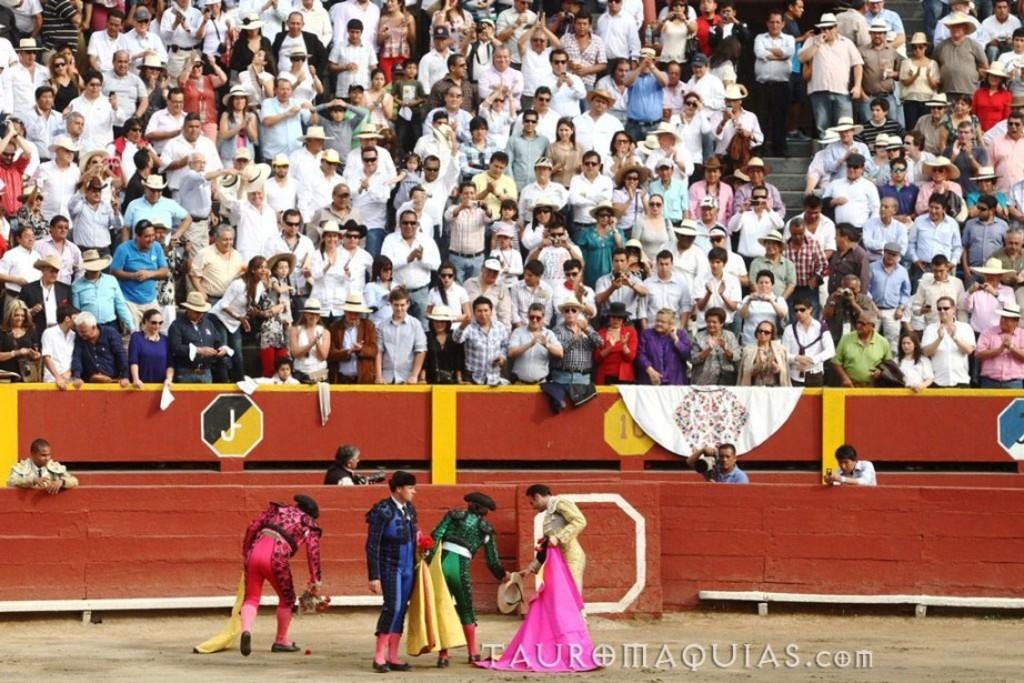What activity are the people in the image participating in? The people in the image are standing in a court and catching a cloth. What type of structure is visible in the background? There is a stadium in the image. How many people are present in the stadium? There are many people standing in the stadium. What can be seen near the court? There is a wooden fence in the image. What type of string is being used to create sound in the image? There is no string or sound present in the image; the people are catching a cloth in a court. What is the head of the person in the image doing? There is no specific person mentioned in the image, and no action related to a head is described in the provided facts. 